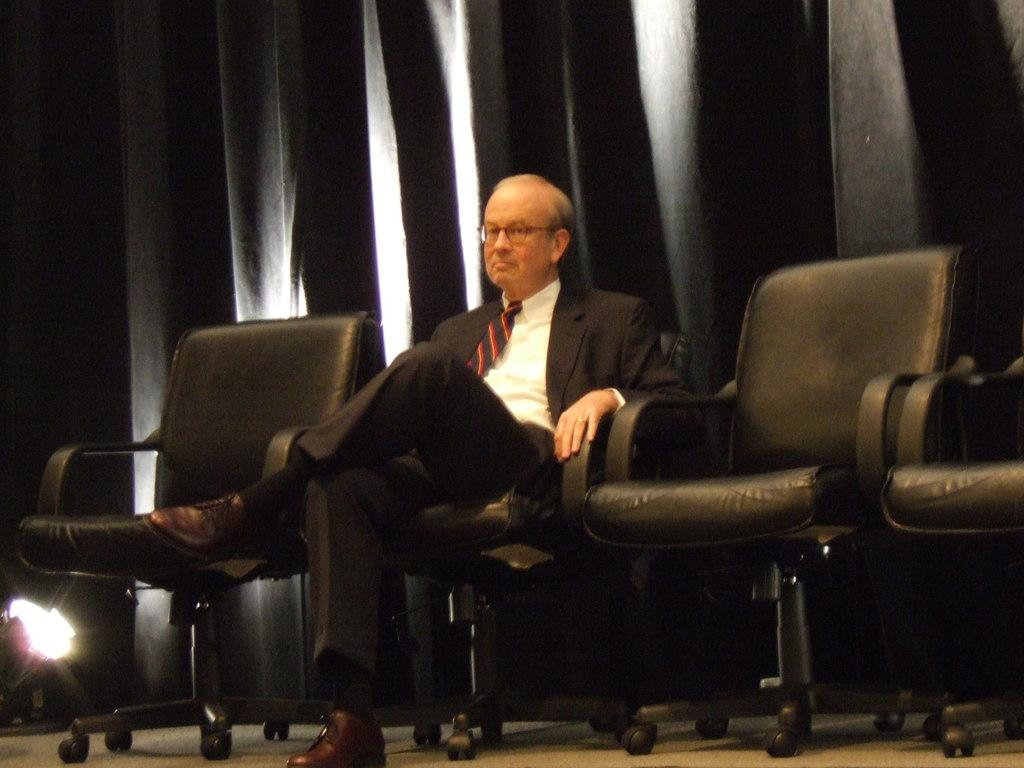What is the main subject of the image? There is a group of chairs in the image. Is anyone sitting on the chairs? Yes, an old man is sitting on one of the chairs. What else can be seen in the image besides the chairs and the old man? There is a curtain visible in the image. How many corks are on the floor in the image? There are no corks visible in the image. What type of sack is the old man carrying in the image? The old man is not carrying a sack in the image. 